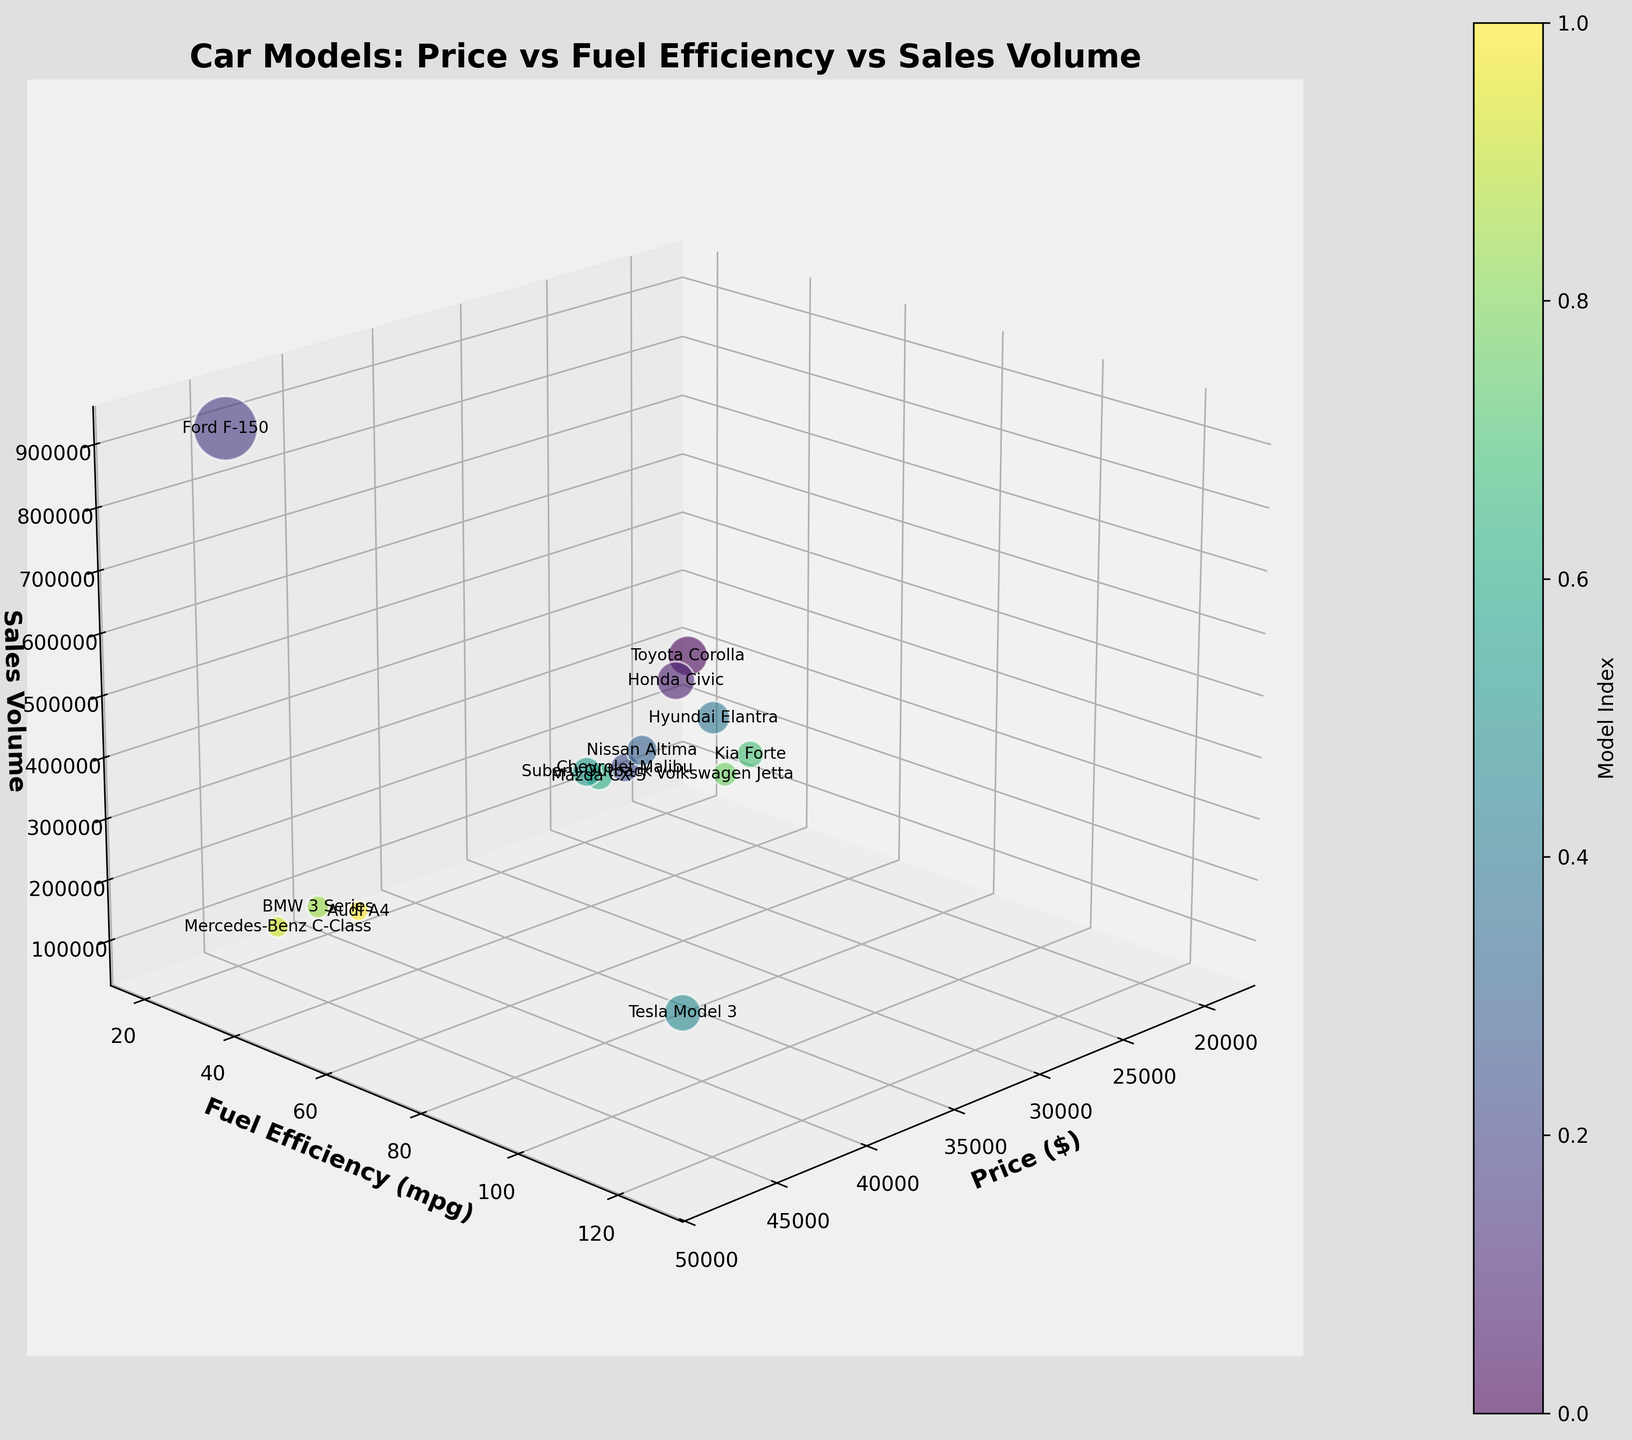What's the title of the figure? The title of the figure is displayed at the top and typically summarizes the content of the plot.
Answer: Car Models: Price vs Fuel Efficiency vs Sales Volume How many car models are displayed in the figure? Count the number of bubbles or text labels representing the car models in the plot.
Answer: 14 Which car model has the highest fuel efficiency? Identify the bubble that is positioned highest along the fuel efficiency (y) axis.
Answer: Tesla Model 3 Which car model has the lowest sales volume? Locate the bubble that is positioned closest to the origin along the sales volume (z) axis.
Answer: Audi A4 What is the price range of the car models in the figure? Look at the minimum and maximum values along the price (x) axis.
Answer: $19,000 to $48,000 What is the average fuel efficiency of the car models? Add up all the fuel efficiency values and divide by the number of models. (32+33+20+29+31+34+125+28+27+35+33+26+25+27)/14 = 41.64
Answer: 41.64 mpg Which car models have a fuel efficiency greater than 30 mpg and a price less than $25,000? Find bubbles where both the y-axis value exceeds 30 and the x-axis value is below 25,000.
Answer: Hyundai Elantra, Kia Forte, Volkswagen Jetta Which car model has a higher price: Ford F-150 or BMW 3 Series? Compare the x-axis positions of the bubbles representing these two models.
Answer: Ford F-150 Is there a correlation between price and sales volume? Observe if there’s a pattern between the x-axis (price) and z-axis (sales volume). Generally, higher-priced cars have lower sales and vice versa.
Answer: Negative correlation Which car model is the most popular (highest sales volume)? Identify the bubble that is positioned highest along the sales volume (z) axis.
Answer: Ford F-150 